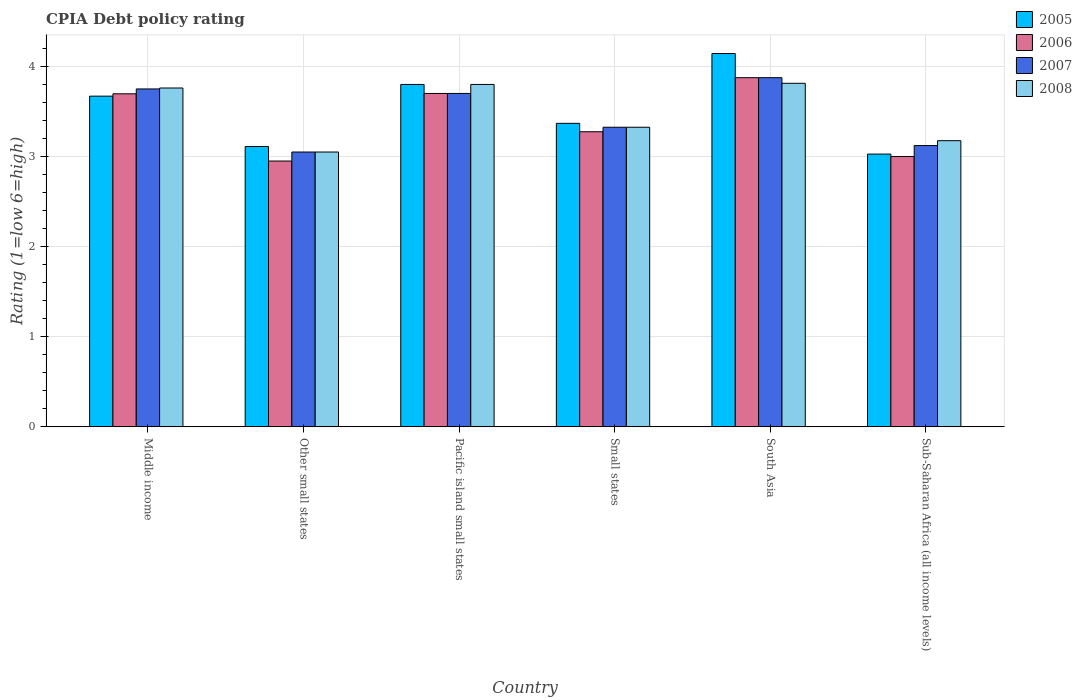How many groups of bars are there?
Your answer should be very brief. 6. How many bars are there on the 4th tick from the left?
Make the answer very short. 4. What is the label of the 4th group of bars from the left?
Your answer should be very brief. Small states. What is the CPIA rating in 2005 in Small states?
Offer a terse response. 3.37. Across all countries, what is the maximum CPIA rating in 2008?
Your answer should be compact. 3.81. Across all countries, what is the minimum CPIA rating in 2005?
Offer a terse response. 3.03. In which country was the CPIA rating in 2007 minimum?
Your answer should be very brief. Other small states. What is the total CPIA rating in 2008 in the graph?
Your answer should be compact. 20.92. What is the difference between the CPIA rating in 2006 in Middle income and that in Sub-Saharan Africa (all income levels)?
Provide a short and direct response. 0.7. What is the difference between the CPIA rating in 2005 in Other small states and the CPIA rating in 2006 in Small states?
Make the answer very short. -0.16. What is the average CPIA rating in 2007 per country?
Keep it short and to the point. 3.47. What is the difference between the CPIA rating of/in 2008 and CPIA rating of/in 2007 in Middle income?
Your answer should be very brief. 0.01. In how many countries, is the CPIA rating in 2006 greater than 2.6?
Ensure brevity in your answer.  6. What is the ratio of the CPIA rating in 2006 in Middle income to that in Sub-Saharan Africa (all income levels)?
Give a very brief answer. 1.23. What is the difference between the highest and the second highest CPIA rating in 2005?
Ensure brevity in your answer.  -0.13. What is the difference between the highest and the lowest CPIA rating in 2005?
Provide a short and direct response. 1.12. In how many countries, is the CPIA rating in 2007 greater than the average CPIA rating in 2007 taken over all countries?
Offer a terse response. 3. Is the sum of the CPIA rating in 2006 in Middle income and Pacific island small states greater than the maximum CPIA rating in 2008 across all countries?
Keep it short and to the point. Yes. What does the 4th bar from the left in Middle income represents?
Provide a short and direct response. 2008. What does the 1st bar from the right in Middle income represents?
Offer a terse response. 2008. Is it the case that in every country, the sum of the CPIA rating in 2007 and CPIA rating in 2006 is greater than the CPIA rating in 2008?
Provide a short and direct response. Yes. How many bars are there?
Keep it short and to the point. 24. Are all the bars in the graph horizontal?
Provide a succinct answer. No. Does the graph contain any zero values?
Offer a terse response. No. Does the graph contain grids?
Keep it short and to the point. Yes. Where does the legend appear in the graph?
Offer a very short reply. Top right. How many legend labels are there?
Ensure brevity in your answer.  4. What is the title of the graph?
Give a very brief answer. CPIA Debt policy rating. What is the label or title of the X-axis?
Your answer should be compact. Country. What is the Rating (1=low 6=high) of 2005 in Middle income?
Provide a short and direct response. 3.67. What is the Rating (1=low 6=high) of 2006 in Middle income?
Your response must be concise. 3.7. What is the Rating (1=low 6=high) of 2007 in Middle income?
Keep it short and to the point. 3.75. What is the Rating (1=low 6=high) in 2008 in Middle income?
Your answer should be compact. 3.76. What is the Rating (1=low 6=high) of 2005 in Other small states?
Provide a succinct answer. 3.11. What is the Rating (1=low 6=high) in 2006 in Other small states?
Your answer should be compact. 2.95. What is the Rating (1=low 6=high) of 2007 in Other small states?
Give a very brief answer. 3.05. What is the Rating (1=low 6=high) of 2008 in Other small states?
Your answer should be compact. 3.05. What is the Rating (1=low 6=high) in 2005 in Pacific island small states?
Your answer should be compact. 3.8. What is the Rating (1=low 6=high) in 2006 in Pacific island small states?
Give a very brief answer. 3.7. What is the Rating (1=low 6=high) of 2007 in Pacific island small states?
Your answer should be compact. 3.7. What is the Rating (1=low 6=high) of 2005 in Small states?
Your response must be concise. 3.37. What is the Rating (1=low 6=high) of 2006 in Small states?
Your answer should be compact. 3.27. What is the Rating (1=low 6=high) of 2007 in Small states?
Ensure brevity in your answer.  3.33. What is the Rating (1=low 6=high) in 2008 in Small states?
Provide a short and direct response. 3.33. What is the Rating (1=low 6=high) in 2005 in South Asia?
Make the answer very short. 4.14. What is the Rating (1=low 6=high) in 2006 in South Asia?
Your response must be concise. 3.88. What is the Rating (1=low 6=high) of 2007 in South Asia?
Ensure brevity in your answer.  3.88. What is the Rating (1=low 6=high) in 2008 in South Asia?
Provide a succinct answer. 3.81. What is the Rating (1=low 6=high) in 2005 in Sub-Saharan Africa (all income levels)?
Ensure brevity in your answer.  3.03. What is the Rating (1=low 6=high) of 2006 in Sub-Saharan Africa (all income levels)?
Your response must be concise. 3. What is the Rating (1=low 6=high) of 2007 in Sub-Saharan Africa (all income levels)?
Your answer should be compact. 3.12. What is the Rating (1=low 6=high) of 2008 in Sub-Saharan Africa (all income levels)?
Provide a succinct answer. 3.18. Across all countries, what is the maximum Rating (1=low 6=high) in 2005?
Ensure brevity in your answer.  4.14. Across all countries, what is the maximum Rating (1=low 6=high) of 2006?
Give a very brief answer. 3.88. Across all countries, what is the maximum Rating (1=low 6=high) in 2007?
Make the answer very short. 3.88. Across all countries, what is the maximum Rating (1=low 6=high) in 2008?
Offer a terse response. 3.81. Across all countries, what is the minimum Rating (1=low 6=high) of 2005?
Keep it short and to the point. 3.03. Across all countries, what is the minimum Rating (1=low 6=high) of 2006?
Offer a very short reply. 2.95. Across all countries, what is the minimum Rating (1=low 6=high) of 2007?
Keep it short and to the point. 3.05. Across all countries, what is the minimum Rating (1=low 6=high) in 2008?
Provide a short and direct response. 3.05. What is the total Rating (1=low 6=high) of 2005 in the graph?
Your response must be concise. 21.12. What is the total Rating (1=low 6=high) in 2006 in the graph?
Give a very brief answer. 20.5. What is the total Rating (1=low 6=high) in 2007 in the graph?
Provide a short and direct response. 20.82. What is the total Rating (1=low 6=high) in 2008 in the graph?
Give a very brief answer. 20.92. What is the difference between the Rating (1=low 6=high) of 2005 in Middle income and that in Other small states?
Your response must be concise. 0.56. What is the difference between the Rating (1=low 6=high) of 2006 in Middle income and that in Other small states?
Keep it short and to the point. 0.75. What is the difference between the Rating (1=low 6=high) in 2007 in Middle income and that in Other small states?
Your answer should be very brief. 0.7. What is the difference between the Rating (1=low 6=high) in 2008 in Middle income and that in Other small states?
Make the answer very short. 0.71. What is the difference between the Rating (1=low 6=high) in 2005 in Middle income and that in Pacific island small states?
Give a very brief answer. -0.13. What is the difference between the Rating (1=low 6=high) in 2006 in Middle income and that in Pacific island small states?
Your response must be concise. -0. What is the difference between the Rating (1=low 6=high) in 2008 in Middle income and that in Pacific island small states?
Give a very brief answer. -0.04. What is the difference between the Rating (1=low 6=high) of 2005 in Middle income and that in Small states?
Offer a very short reply. 0.3. What is the difference between the Rating (1=low 6=high) in 2006 in Middle income and that in Small states?
Give a very brief answer. 0.42. What is the difference between the Rating (1=low 6=high) of 2007 in Middle income and that in Small states?
Provide a succinct answer. 0.42. What is the difference between the Rating (1=low 6=high) of 2008 in Middle income and that in Small states?
Make the answer very short. 0.44. What is the difference between the Rating (1=low 6=high) in 2005 in Middle income and that in South Asia?
Offer a very short reply. -0.47. What is the difference between the Rating (1=low 6=high) of 2006 in Middle income and that in South Asia?
Provide a succinct answer. -0.18. What is the difference between the Rating (1=low 6=high) in 2007 in Middle income and that in South Asia?
Your response must be concise. -0.12. What is the difference between the Rating (1=low 6=high) of 2008 in Middle income and that in South Asia?
Offer a terse response. -0.05. What is the difference between the Rating (1=low 6=high) of 2005 in Middle income and that in Sub-Saharan Africa (all income levels)?
Your answer should be compact. 0.64. What is the difference between the Rating (1=low 6=high) of 2006 in Middle income and that in Sub-Saharan Africa (all income levels)?
Provide a short and direct response. 0.7. What is the difference between the Rating (1=low 6=high) in 2007 in Middle income and that in Sub-Saharan Africa (all income levels)?
Give a very brief answer. 0.63. What is the difference between the Rating (1=low 6=high) in 2008 in Middle income and that in Sub-Saharan Africa (all income levels)?
Provide a succinct answer. 0.58. What is the difference between the Rating (1=low 6=high) in 2005 in Other small states and that in Pacific island small states?
Provide a succinct answer. -0.69. What is the difference between the Rating (1=low 6=high) of 2006 in Other small states and that in Pacific island small states?
Keep it short and to the point. -0.75. What is the difference between the Rating (1=low 6=high) in 2007 in Other small states and that in Pacific island small states?
Offer a very short reply. -0.65. What is the difference between the Rating (1=low 6=high) in 2008 in Other small states and that in Pacific island small states?
Keep it short and to the point. -0.75. What is the difference between the Rating (1=low 6=high) of 2005 in Other small states and that in Small states?
Provide a short and direct response. -0.26. What is the difference between the Rating (1=low 6=high) of 2006 in Other small states and that in Small states?
Keep it short and to the point. -0.33. What is the difference between the Rating (1=low 6=high) in 2007 in Other small states and that in Small states?
Keep it short and to the point. -0.28. What is the difference between the Rating (1=low 6=high) in 2008 in Other small states and that in Small states?
Offer a very short reply. -0.28. What is the difference between the Rating (1=low 6=high) in 2005 in Other small states and that in South Asia?
Offer a very short reply. -1.03. What is the difference between the Rating (1=low 6=high) in 2006 in Other small states and that in South Asia?
Keep it short and to the point. -0.93. What is the difference between the Rating (1=low 6=high) of 2007 in Other small states and that in South Asia?
Provide a short and direct response. -0.82. What is the difference between the Rating (1=low 6=high) in 2008 in Other small states and that in South Asia?
Keep it short and to the point. -0.76. What is the difference between the Rating (1=low 6=high) in 2005 in Other small states and that in Sub-Saharan Africa (all income levels)?
Make the answer very short. 0.08. What is the difference between the Rating (1=low 6=high) in 2006 in Other small states and that in Sub-Saharan Africa (all income levels)?
Offer a terse response. -0.05. What is the difference between the Rating (1=low 6=high) of 2007 in Other small states and that in Sub-Saharan Africa (all income levels)?
Provide a short and direct response. -0.07. What is the difference between the Rating (1=low 6=high) of 2008 in Other small states and that in Sub-Saharan Africa (all income levels)?
Provide a succinct answer. -0.13. What is the difference between the Rating (1=low 6=high) of 2005 in Pacific island small states and that in Small states?
Offer a very short reply. 0.43. What is the difference between the Rating (1=low 6=high) of 2006 in Pacific island small states and that in Small states?
Give a very brief answer. 0.42. What is the difference between the Rating (1=low 6=high) in 2008 in Pacific island small states and that in Small states?
Provide a succinct answer. 0.47. What is the difference between the Rating (1=low 6=high) in 2005 in Pacific island small states and that in South Asia?
Your response must be concise. -0.34. What is the difference between the Rating (1=low 6=high) of 2006 in Pacific island small states and that in South Asia?
Your answer should be very brief. -0.17. What is the difference between the Rating (1=low 6=high) in 2007 in Pacific island small states and that in South Asia?
Give a very brief answer. -0.17. What is the difference between the Rating (1=low 6=high) in 2008 in Pacific island small states and that in South Asia?
Your answer should be very brief. -0.01. What is the difference between the Rating (1=low 6=high) of 2005 in Pacific island small states and that in Sub-Saharan Africa (all income levels)?
Your answer should be very brief. 0.77. What is the difference between the Rating (1=low 6=high) of 2007 in Pacific island small states and that in Sub-Saharan Africa (all income levels)?
Your response must be concise. 0.58. What is the difference between the Rating (1=low 6=high) of 2008 in Pacific island small states and that in Sub-Saharan Africa (all income levels)?
Give a very brief answer. 0.62. What is the difference between the Rating (1=low 6=high) of 2005 in Small states and that in South Asia?
Give a very brief answer. -0.77. What is the difference between the Rating (1=low 6=high) of 2006 in Small states and that in South Asia?
Provide a succinct answer. -0.6. What is the difference between the Rating (1=low 6=high) in 2007 in Small states and that in South Asia?
Offer a terse response. -0.55. What is the difference between the Rating (1=low 6=high) in 2008 in Small states and that in South Asia?
Make the answer very short. -0.49. What is the difference between the Rating (1=low 6=high) of 2005 in Small states and that in Sub-Saharan Africa (all income levels)?
Provide a short and direct response. 0.34. What is the difference between the Rating (1=low 6=high) of 2006 in Small states and that in Sub-Saharan Africa (all income levels)?
Offer a very short reply. 0.28. What is the difference between the Rating (1=low 6=high) in 2007 in Small states and that in Sub-Saharan Africa (all income levels)?
Your answer should be compact. 0.2. What is the difference between the Rating (1=low 6=high) of 2008 in Small states and that in Sub-Saharan Africa (all income levels)?
Offer a terse response. 0.15. What is the difference between the Rating (1=low 6=high) in 2005 in South Asia and that in Sub-Saharan Africa (all income levels)?
Make the answer very short. 1.12. What is the difference between the Rating (1=low 6=high) of 2007 in South Asia and that in Sub-Saharan Africa (all income levels)?
Ensure brevity in your answer.  0.75. What is the difference between the Rating (1=low 6=high) in 2008 in South Asia and that in Sub-Saharan Africa (all income levels)?
Your answer should be compact. 0.64. What is the difference between the Rating (1=low 6=high) of 2005 in Middle income and the Rating (1=low 6=high) of 2006 in Other small states?
Your answer should be very brief. 0.72. What is the difference between the Rating (1=low 6=high) in 2005 in Middle income and the Rating (1=low 6=high) in 2007 in Other small states?
Your answer should be very brief. 0.62. What is the difference between the Rating (1=low 6=high) in 2005 in Middle income and the Rating (1=low 6=high) in 2008 in Other small states?
Your answer should be compact. 0.62. What is the difference between the Rating (1=low 6=high) of 2006 in Middle income and the Rating (1=low 6=high) of 2007 in Other small states?
Your answer should be compact. 0.65. What is the difference between the Rating (1=low 6=high) of 2006 in Middle income and the Rating (1=low 6=high) of 2008 in Other small states?
Ensure brevity in your answer.  0.65. What is the difference between the Rating (1=low 6=high) of 2005 in Middle income and the Rating (1=low 6=high) of 2006 in Pacific island small states?
Provide a succinct answer. -0.03. What is the difference between the Rating (1=low 6=high) of 2005 in Middle income and the Rating (1=low 6=high) of 2007 in Pacific island small states?
Keep it short and to the point. -0.03. What is the difference between the Rating (1=low 6=high) of 2005 in Middle income and the Rating (1=low 6=high) of 2008 in Pacific island small states?
Offer a very short reply. -0.13. What is the difference between the Rating (1=low 6=high) of 2006 in Middle income and the Rating (1=low 6=high) of 2007 in Pacific island small states?
Provide a succinct answer. -0. What is the difference between the Rating (1=low 6=high) in 2006 in Middle income and the Rating (1=low 6=high) in 2008 in Pacific island small states?
Your response must be concise. -0.1. What is the difference between the Rating (1=low 6=high) in 2005 in Middle income and the Rating (1=low 6=high) in 2006 in Small states?
Make the answer very short. 0.4. What is the difference between the Rating (1=low 6=high) of 2005 in Middle income and the Rating (1=low 6=high) of 2007 in Small states?
Ensure brevity in your answer.  0.34. What is the difference between the Rating (1=low 6=high) of 2005 in Middle income and the Rating (1=low 6=high) of 2008 in Small states?
Your answer should be compact. 0.34. What is the difference between the Rating (1=low 6=high) in 2006 in Middle income and the Rating (1=low 6=high) in 2007 in Small states?
Offer a terse response. 0.37. What is the difference between the Rating (1=low 6=high) of 2006 in Middle income and the Rating (1=low 6=high) of 2008 in Small states?
Provide a succinct answer. 0.37. What is the difference between the Rating (1=low 6=high) in 2007 in Middle income and the Rating (1=low 6=high) in 2008 in Small states?
Offer a very short reply. 0.42. What is the difference between the Rating (1=low 6=high) of 2005 in Middle income and the Rating (1=low 6=high) of 2006 in South Asia?
Your answer should be very brief. -0.2. What is the difference between the Rating (1=low 6=high) of 2005 in Middle income and the Rating (1=low 6=high) of 2007 in South Asia?
Your answer should be compact. -0.2. What is the difference between the Rating (1=low 6=high) of 2005 in Middle income and the Rating (1=low 6=high) of 2008 in South Asia?
Your response must be concise. -0.14. What is the difference between the Rating (1=low 6=high) of 2006 in Middle income and the Rating (1=low 6=high) of 2007 in South Asia?
Provide a succinct answer. -0.18. What is the difference between the Rating (1=low 6=high) in 2006 in Middle income and the Rating (1=low 6=high) in 2008 in South Asia?
Keep it short and to the point. -0.12. What is the difference between the Rating (1=low 6=high) of 2007 in Middle income and the Rating (1=low 6=high) of 2008 in South Asia?
Make the answer very short. -0.06. What is the difference between the Rating (1=low 6=high) of 2005 in Middle income and the Rating (1=low 6=high) of 2006 in Sub-Saharan Africa (all income levels)?
Offer a very short reply. 0.67. What is the difference between the Rating (1=low 6=high) in 2005 in Middle income and the Rating (1=low 6=high) in 2007 in Sub-Saharan Africa (all income levels)?
Offer a very short reply. 0.55. What is the difference between the Rating (1=low 6=high) of 2005 in Middle income and the Rating (1=low 6=high) of 2008 in Sub-Saharan Africa (all income levels)?
Your answer should be very brief. 0.49. What is the difference between the Rating (1=low 6=high) of 2006 in Middle income and the Rating (1=low 6=high) of 2007 in Sub-Saharan Africa (all income levels)?
Your response must be concise. 0.57. What is the difference between the Rating (1=low 6=high) in 2006 in Middle income and the Rating (1=low 6=high) in 2008 in Sub-Saharan Africa (all income levels)?
Your answer should be compact. 0.52. What is the difference between the Rating (1=low 6=high) of 2007 in Middle income and the Rating (1=low 6=high) of 2008 in Sub-Saharan Africa (all income levels)?
Your answer should be very brief. 0.57. What is the difference between the Rating (1=low 6=high) of 2005 in Other small states and the Rating (1=low 6=high) of 2006 in Pacific island small states?
Make the answer very short. -0.59. What is the difference between the Rating (1=low 6=high) in 2005 in Other small states and the Rating (1=low 6=high) in 2007 in Pacific island small states?
Offer a very short reply. -0.59. What is the difference between the Rating (1=low 6=high) in 2005 in Other small states and the Rating (1=low 6=high) in 2008 in Pacific island small states?
Your response must be concise. -0.69. What is the difference between the Rating (1=low 6=high) of 2006 in Other small states and the Rating (1=low 6=high) of 2007 in Pacific island small states?
Ensure brevity in your answer.  -0.75. What is the difference between the Rating (1=low 6=high) in 2006 in Other small states and the Rating (1=low 6=high) in 2008 in Pacific island small states?
Make the answer very short. -0.85. What is the difference between the Rating (1=low 6=high) in 2007 in Other small states and the Rating (1=low 6=high) in 2008 in Pacific island small states?
Offer a terse response. -0.75. What is the difference between the Rating (1=low 6=high) of 2005 in Other small states and the Rating (1=low 6=high) of 2006 in Small states?
Keep it short and to the point. -0.16. What is the difference between the Rating (1=low 6=high) of 2005 in Other small states and the Rating (1=low 6=high) of 2007 in Small states?
Give a very brief answer. -0.21. What is the difference between the Rating (1=low 6=high) of 2005 in Other small states and the Rating (1=low 6=high) of 2008 in Small states?
Provide a succinct answer. -0.21. What is the difference between the Rating (1=low 6=high) of 2006 in Other small states and the Rating (1=low 6=high) of 2007 in Small states?
Your answer should be very brief. -0.38. What is the difference between the Rating (1=low 6=high) in 2006 in Other small states and the Rating (1=low 6=high) in 2008 in Small states?
Your answer should be very brief. -0.38. What is the difference between the Rating (1=low 6=high) of 2007 in Other small states and the Rating (1=low 6=high) of 2008 in Small states?
Provide a short and direct response. -0.28. What is the difference between the Rating (1=low 6=high) in 2005 in Other small states and the Rating (1=low 6=high) in 2006 in South Asia?
Give a very brief answer. -0.76. What is the difference between the Rating (1=low 6=high) of 2005 in Other small states and the Rating (1=low 6=high) of 2007 in South Asia?
Provide a short and direct response. -0.76. What is the difference between the Rating (1=low 6=high) of 2005 in Other small states and the Rating (1=low 6=high) of 2008 in South Asia?
Provide a short and direct response. -0.7. What is the difference between the Rating (1=low 6=high) of 2006 in Other small states and the Rating (1=low 6=high) of 2007 in South Asia?
Ensure brevity in your answer.  -0.93. What is the difference between the Rating (1=low 6=high) in 2006 in Other small states and the Rating (1=low 6=high) in 2008 in South Asia?
Make the answer very short. -0.86. What is the difference between the Rating (1=low 6=high) in 2007 in Other small states and the Rating (1=low 6=high) in 2008 in South Asia?
Give a very brief answer. -0.76. What is the difference between the Rating (1=low 6=high) of 2005 in Other small states and the Rating (1=low 6=high) of 2007 in Sub-Saharan Africa (all income levels)?
Your response must be concise. -0.01. What is the difference between the Rating (1=low 6=high) of 2005 in Other small states and the Rating (1=low 6=high) of 2008 in Sub-Saharan Africa (all income levels)?
Provide a succinct answer. -0.06. What is the difference between the Rating (1=low 6=high) of 2006 in Other small states and the Rating (1=low 6=high) of 2007 in Sub-Saharan Africa (all income levels)?
Your response must be concise. -0.17. What is the difference between the Rating (1=low 6=high) in 2006 in Other small states and the Rating (1=low 6=high) in 2008 in Sub-Saharan Africa (all income levels)?
Ensure brevity in your answer.  -0.23. What is the difference between the Rating (1=low 6=high) in 2007 in Other small states and the Rating (1=low 6=high) in 2008 in Sub-Saharan Africa (all income levels)?
Offer a terse response. -0.13. What is the difference between the Rating (1=low 6=high) of 2005 in Pacific island small states and the Rating (1=low 6=high) of 2006 in Small states?
Your answer should be compact. 0.53. What is the difference between the Rating (1=low 6=high) of 2005 in Pacific island small states and the Rating (1=low 6=high) of 2007 in Small states?
Provide a short and direct response. 0.47. What is the difference between the Rating (1=low 6=high) of 2005 in Pacific island small states and the Rating (1=low 6=high) of 2008 in Small states?
Offer a very short reply. 0.47. What is the difference between the Rating (1=low 6=high) in 2007 in Pacific island small states and the Rating (1=low 6=high) in 2008 in Small states?
Give a very brief answer. 0.38. What is the difference between the Rating (1=low 6=high) in 2005 in Pacific island small states and the Rating (1=low 6=high) in 2006 in South Asia?
Give a very brief answer. -0.07. What is the difference between the Rating (1=low 6=high) in 2005 in Pacific island small states and the Rating (1=low 6=high) in 2007 in South Asia?
Make the answer very short. -0.07. What is the difference between the Rating (1=low 6=high) of 2005 in Pacific island small states and the Rating (1=low 6=high) of 2008 in South Asia?
Keep it short and to the point. -0.01. What is the difference between the Rating (1=low 6=high) of 2006 in Pacific island small states and the Rating (1=low 6=high) of 2007 in South Asia?
Keep it short and to the point. -0.17. What is the difference between the Rating (1=low 6=high) of 2006 in Pacific island small states and the Rating (1=low 6=high) of 2008 in South Asia?
Make the answer very short. -0.11. What is the difference between the Rating (1=low 6=high) in 2007 in Pacific island small states and the Rating (1=low 6=high) in 2008 in South Asia?
Provide a succinct answer. -0.11. What is the difference between the Rating (1=low 6=high) of 2005 in Pacific island small states and the Rating (1=low 6=high) of 2006 in Sub-Saharan Africa (all income levels)?
Make the answer very short. 0.8. What is the difference between the Rating (1=low 6=high) in 2005 in Pacific island small states and the Rating (1=low 6=high) in 2007 in Sub-Saharan Africa (all income levels)?
Give a very brief answer. 0.68. What is the difference between the Rating (1=low 6=high) of 2005 in Pacific island small states and the Rating (1=low 6=high) of 2008 in Sub-Saharan Africa (all income levels)?
Offer a terse response. 0.62. What is the difference between the Rating (1=low 6=high) in 2006 in Pacific island small states and the Rating (1=low 6=high) in 2007 in Sub-Saharan Africa (all income levels)?
Make the answer very short. 0.58. What is the difference between the Rating (1=low 6=high) of 2006 in Pacific island small states and the Rating (1=low 6=high) of 2008 in Sub-Saharan Africa (all income levels)?
Make the answer very short. 0.52. What is the difference between the Rating (1=low 6=high) in 2007 in Pacific island small states and the Rating (1=low 6=high) in 2008 in Sub-Saharan Africa (all income levels)?
Provide a short and direct response. 0.52. What is the difference between the Rating (1=low 6=high) of 2005 in Small states and the Rating (1=low 6=high) of 2006 in South Asia?
Give a very brief answer. -0.51. What is the difference between the Rating (1=low 6=high) in 2005 in Small states and the Rating (1=low 6=high) in 2007 in South Asia?
Give a very brief answer. -0.51. What is the difference between the Rating (1=low 6=high) of 2005 in Small states and the Rating (1=low 6=high) of 2008 in South Asia?
Make the answer very short. -0.44. What is the difference between the Rating (1=low 6=high) of 2006 in Small states and the Rating (1=low 6=high) of 2008 in South Asia?
Give a very brief answer. -0.54. What is the difference between the Rating (1=low 6=high) in 2007 in Small states and the Rating (1=low 6=high) in 2008 in South Asia?
Offer a terse response. -0.49. What is the difference between the Rating (1=low 6=high) of 2005 in Small states and the Rating (1=low 6=high) of 2006 in Sub-Saharan Africa (all income levels)?
Offer a terse response. 0.37. What is the difference between the Rating (1=low 6=high) in 2005 in Small states and the Rating (1=low 6=high) in 2007 in Sub-Saharan Africa (all income levels)?
Provide a short and direct response. 0.25. What is the difference between the Rating (1=low 6=high) of 2005 in Small states and the Rating (1=low 6=high) of 2008 in Sub-Saharan Africa (all income levels)?
Offer a very short reply. 0.19. What is the difference between the Rating (1=low 6=high) of 2006 in Small states and the Rating (1=low 6=high) of 2007 in Sub-Saharan Africa (all income levels)?
Give a very brief answer. 0.15. What is the difference between the Rating (1=low 6=high) of 2006 in Small states and the Rating (1=low 6=high) of 2008 in Sub-Saharan Africa (all income levels)?
Offer a very short reply. 0.1. What is the difference between the Rating (1=low 6=high) of 2007 in Small states and the Rating (1=low 6=high) of 2008 in Sub-Saharan Africa (all income levels)?
Provide a succinct answer. 0.15. What is the difference between the Rating (1=low 6=high) of 2005 in South Asia and the Rating (1=low 6=high) of 2007 in Sub-Saharan Africa (all income levels)?
Your answer should be very brief. 1.02. What is the difference between the Rating (1=low 6=high) of 2005 in South Asia and the Rating (1=low 6=high) of 2008 in Sub-Saharan Africa (all income levels)?
Your answer should be compact. 0.97. What is the difference between the Rating (1=low 6=high) in 2006 in South Asia and the Rating (1=low 6=high) in 2007 in Sub-Saharan Africa (all income levels)?
Your answer should be very brief. 0.75. What is the difference between the Rating (1=low 6=high) of 2006 in South Asia and the Rating (1=low 6=high) of 2008 in Sub-Saharan Africa (all income levels)?
Provide a short and direct response. 0.7. What is the difference between the Rating (1=low 6=high) in 2007 in South Asia and the Rating (1=low 6=high) in 2008 in Sub-Saharan Africa (all income levels)?
Your answer should be very brief. 0.7. What is the average Rating (1=low 6=high) in 2005 per country?
Offer a very short reply. 3.52. What is the average Rating (1=low 6=high) of 2006 per country?
Make the answer very short. 3.42. What is the average Rating (1=low 6=high) of 2007 per country?
Offer a very short reply. 3.47. What is the average Rating (1=low 6=high) of 2008 per country?
Keep it short and to the point. 3.49. What is the difference between the Rating (1=low 6=high) in 2005 and Rating (1=low 6=high) in 2006 in Middle income?
Offer a terse response. -0.03. What is the difference between the Rating (1=low 6=high) in 2005 and Rating (1=low 6=high) in 2007 in Middle income?
Offer a terse response. -0.08. What is the difference between the Rating (1=low 6=high) of 2005 and Rating (1=low 6=high) of 2008 in Middle income?
Ensure brevity in your answer.  -0.09. What is the difference between the Rating (1=low 6=high) of 2006 and Rating (1=low 6=high) of 2007 in Middle income?
Make the answer very short. -0.05. What is the difference between the Rating (1=low 6=high) in 2006 and Rating (1=low 6=high) in 2008 in Middle income?
Your answer should be very brief. -0.06. What is the difference between the Rating (1=low 6=high) of 2007 and Rating (1=low 6=high) of 2008 in Middle income?
Provide a succinct answer. -0.01. What is the difference between the Rating (1=low 6=high) in 2005 and Rating (1=low 6=high) in 2006 in Other small states?
Provide a short and direct response. 0.16. What is the difference between the Rating (1=low 6=high) in 2005 and Rating (1=low 6=high) in 2007 in Other small states?
Make the answer very short. 0.06. What is the difference between the Rating (1=low 6=high) in 2005 and Rating (1=low 6=high) in 2008 in Other small states?
Provide a succinct answer. 0.06. What is the difference between the Rating (1=low 6=high) in 2007 and Rating (1=low 6=high) in 2008 in Other small states?
Give a very brief answer. 0. What is the difference between the Rating (1=low 6=high) of 2005 and Rating (1=low 6=high) of 2006 in Pacific island small states?
Provide a succinct answer. 0.1. What is the difference between the Rating (1=low 6=high) in 2005 and Rating (1=low 6=high) in 2008 in Pacific island small states?
Make the answer very short. 0. What is the difference between the Rating (1=low 6=high) of 2006 and Rating (1=low 6=high) of 2008 in Pacific island small states?
Offer a very short reply. -0.1. What is the difference between the Rating (1=low 6=high) in 2007 and Rating (1=low 6=high) in 2008 in Pacific island small states?
Provide a succinct answer. -0.1. What is the difference between the Rating (1=low 6=high) of 2005 and Rating (1=low 6=high) of 2006 in Small states?
Your answer should be compact. 0.09. What is the difference between the Rating (1=low 6=high) of 2005 and Rating (1=low 6=high) of 2007 in Small states?
Provide a short and direct response. 0.04. What is the difference between the Rating (1=low 6=high) of 2005 and Rating (1=low 6=high) of 2008 in Small states?
Provide a succinct answer. 0.04. What is the difference between the Rating (1=low 6=high) in 2006 and Rating (1=low 6=high) in 2007 in Small states?
Your response must be concise. -0.05. What is the difference between the Rating (1=low 6=high) in 2006 and Rating (1=low 6=high) in 2008 in Small states?
Make the answer very short. -0.05. What is the difference between the Rating (1=low 6=high) in 2005 and Rating (1=low 6=high) in 2006 in South Asia?
Your answer should be very brief. 0.27. What is the difference between the Rating (1=low 6=high) of 2005 and Rating (1=low 6=high) of 2007 in South Asia?
Provide a short and direct response. 0.27. What is the difference between the Rating (1=low 6=high) of 2005 and Rating (1=low 6=high) of 2008 in South Asia?
Ensure brevity in your answer.  0.33. What is the difference between the Rating (1=low 6=high) in 2006 and Rating (1=low 6=high) in 2007 in South Asia?
Ensure brevity in your answer.  0. What is the difference between the Rating (1=low 6=high) of 2006 and Rating (1=low 6=high) of 2008 in South Asia?
Your answer should be very brief. 0.06. What is the difference between the Rating (1=low 6=high) of 2007 and Rating (1=low 6=high) of 2008 in South Asia?
Offer a terse response. 0.06. What is the difference between the Rating (1=low 6=high) of 2005 and Rating (1=low 6=high) of 2006 in Sub-Saharan Africa (all income levels)?
Provide a short and direct response. 0.03. What is the difference between the Rating (1=low 6=high) of 2005 and Rating (1=low 6=high) of 2007 in Sub-Saharan Africa (all income levels)?
Give a very brief answer. -0.09. What is the difference between the Rating (1=low 6=high) in 2005 and Rating (1=low 6=high) in 2008 in Sub-Saharan Africa (all income levels)?
Make the answer very short. -0.15. What is the difference between the Rating (1=low 6=high) of 2006 and Rating (1=low 6=high) of 2007 in Sub-Saharan Africa (all income levels)?
Offer a terse response. -0.12. What is the difference between the Rating (1=low 6=high) of 2006 and Rating (1=low 6=high) of 2008 in Sub-Saharan Africa (all income levels)?
Offer a very short reply. -0.18. What is the difference between the Rating (1=low 6=high) in 2007 and Rating (1=low 6=high) in 2008 in Sub-Saharan Africa (all income levels)?
Keep it short and to the point. -0.05. What is the ratio of the Rating (1=low 6=high) of 2005 in Middle income to that in Other small states?
Give a very brief answer. 1.18. What is the ratio of the Rating (1=low 6=high) of 2006 in Middle income to that in Other small states?
Ensure brevity in your answer.  1.25. What is the ratio of the Rating (1=low 6=high) in 2007 in Middle income to that in Other small states?
Offer a very short reply. 1.23. What is the ratio of the Rating (1=low 6=high) of 2008 in Middle income to that in Other small states?
Your answer should be compact. 1.23. What is the ratio of the Rating (1=low 6=high) in 2005 in Middle income to that in Pacific island small states?
Your response must be concise. 0.97. What is the ratio of the Rating (1=low 6=high) of 2007 in Middle income to that in Pacific island small states?
Ensure brevity in your answer.  1.01. What is the ratio of the Rating (1=low 6=high) in 2005 in Middle income to that in Small states?
Give a very brief answer. 1.09. What is the ratio of the Rating (1=low 6=high) in 2006 in Middle income to that in Small states?
Ensure brevity in your answer.  1.13. What is the ratio of the Rating (1=low 6=high) in 2007 in Middle income to that in Small states?
Ensure brevity in your answer.  1.13. What is the ratio of the Rating (1=low 6=high) of 2008 in Middle income to that in Small states?
Your response must be concise. 1.13. What is the ratio of the Rating (1=low 6=high) of 2005 in Middle income to that in South Asia?
Make the answer very short. 0.89. What is the ratio of the Rating (1=low 6=high) in 2006 in Middle income to that in South Asia?
Ensure brevity in your answer.  0.95. What is the ratio of the Rating (1=low 6=high) in 2007 in Middle income to that in South Asia?
Provide a succinct answer. 0.97. What is the ratio of the Rating (1=low 6=high) in 2008 in Middle income to that in South Asia?
Provide a succinct answer. 0.99. What is the ratio of the Rating (1=low 6=high) of 2005 in Middle income to that in Sub-Saharan Africa (all income levels)?
Give a very brief answer. 1.21. What is the ratio of the Rating (1=low 6=high) in 2006 in Middle income to that in Sub-Saharan Africa (all income levels)?
Offer a terse response. 1.23. What is the ratio of the Rating (1=low 6=high) in 2007 in Middle income to that in Sub-Saharan Africa (all income levels)?
Make the answer very short. 1.2. What is the ratio of the Rating (1=low 6=high) of 2008 in Middle income to that in Sub-Saharan Africa (all income levels)?
Your answer should be compact. 1.18. What is the ratio of the Rating (1=low 6=high) in 2005 in Other small states to that in Pacific island small states?
Your response must be concise. 0.82. What is the ratio of the Rating (1=low 6=high) in 2006 in Other small states to that in Pacific island small states?
Your answer should be compact. 0.8. What is the ratio of the Rating (1=low 6=high) in 2007 in Other small states to that in Pacific island small states?
Your response must be concise. 0.82. What is the ratio of the Rating (1=low 6=high) in 2008 in Other small states to that in Pacific island small states?
Your response must be concise. 0.8. What is the ratio of the Rating (1=low 6=high) in 2005 in Other small states to that in Small states?
Offer a terse response. 0.92. What is the ratio of the Rating (1=low 6=high) of 2006 in Other small states to that in Small states?
Offer a very short reply. 0.9. What is the ratio of the Rating (1=low 6=high) of 2007 in Other small states to that in Small states?
Provide a short and direct response. 0.92. What is the ratio of the Rating (1=low 6=high) in 2008 in Other small states to that in Small states?
Offer a very short reply. 0.92. What is the ratio of the Rating (1=low 6=high) of 2005 in Other small states to that in South Asia?
Your answer should be compact. 0.75. What is the ratio of the Rating (1=low 6=high) in 2006 in Other small states to that in South Asia?
Ensure brevity in your answer.  0.76. What is the ratio of the Rating (1=low 6=high) in 2007 in Other small states to that in South Asia?
Provide a short and direct response. 0.79. What is the ratio of the Rating (1=low 6=high) of 2005 in Other small states to that in Sub-Saharan Africa (all income levels)?
Your response must be concise. 1.03. What is the ratio of the Rating (1=low 6=high) of 2006 in Other small states to that in Sub-Saharan Africa (all income levels)?
Offer a very short reply. 0.98. What is the ratio of the Rating (1=low 6=high) in 2007 in Other small states to that in Sub-Saharan Africa (all income levels)?
Provide a succinct answer. 0.98. What is the ratio of the Rating (1=low 6=high) of 2008 in Other small states to that in Sub-Saharan Africa (all income levels)?
Give a very brief answer. 0.96. What is the ratio of the Rating (1=low 6=high) in 2005 in Pacific island small states to that in Small states?
Ensure brevity in your answer.  1.13. What is the ratio of the Rating (1=low 6=high) in 2006 in Pacific island small states to that in Small states?
Make the answer very short. 1.13. What is the ratio of the Rating (1=low 6=high) in 2007 in Pacific island small states to that in Small states?
Make the answer very short. 1.11. What is the ratio of the Rating (1=low 6=high) in 2008 in Pacific island small states to that in Small states?
Provide a succinct answer. 1.14. What is the ratio of the Rating (1=low 6=high) in 2005 in Pacific island small states to that in South Asia?
Provide a short and direct response. 0.92. What is the ratio of the Rating (1=low 6=high) of 2006 in Pacific island small states to that in South Asia?
Make the answer very short. 0.95. What is the ratio of the Rating (1=low 6=high) of 2007 in Pacific island small states to that in South Asia?
Your answer should be very brief. 0.95. What is the ratio of the Rating (1=low 6=high) of 2005 in Pacific island small states to that in Sub-Saharan Africa (all income levels)?
Your response must be concise. 1.26. What is the ratio of the Rating (1=low 6=high) in 2006 in Pacific island small states to that in Sub-Saharan Africa (all income levels)?
Your answer should be very brief. 1.23. What is the ratio of the Rating (1=low 6=high) in 2007 in Pacific island small states to that in Sub-Saharan Africa (all income levels)?
Your response must be concise. 1.19. What is the ratio of the Rating (1=low 6=high) of 2008 in Pacific island small states to that in Sub-Saharan Africa (all income levels)?
Ensure brevity in your answer.  1.2. What is the ratio of the Rating (1=low 6=high) in 2005 in Small states to that in South Asia?
Make the answer very short. 0.81. What is the ratio of the Rating (1=low 6=high) in 2006 in Small states to that in South Asia?
Your response must be concise. 0.85. What is the ratio of the Rating (1=low 6=high) in 2007 in Small states to that in South Asia?
Your answer should be compact. 0.86. What is the ratio of the Rating (1=low 6=high) of 2008 in Small states to that in South Asia?
Make the answer very short. 0.87. What is the ratio of the Rating (1=low 6=high) of 2005 in Small states to that in Sub-Saharan Africa (all income levels)?
Offer a terse response. 1.11. What is the ratio of the Rating (1=low 6=high) in 2006 in Small states to that in Sub-Saharan Africa (all income levels)?
Offer a very short reply. 1.09. What is the ratio of the Rating (1=low 6=high) of 2007 in Small states to that in Sub-Saharan Africa (all income levels)?
Provide a short and direct response. 1.07. What is the ratio of the Rating (1=low 6=high) of 2008 in Small states to that in Sub-Saharan Africa (all income levels)?
Your answer should be very brief. 1.05. What is the ratio of the Rating (1=low 6=high) in 2005 in South Asia to that in Sub-Saharan Africa (all income levels)?
Offer a very short reply. 1.37. What is the ratio of the Rating (1=low 6=high) in 2006 in South Asia to that in Sub-Saharan Africa (all income levels)?
Your answer should be very brief. 1.29. What is the ratio of the Rating (1=low 6=high) in 2007 in South Asia to that in Sub-Saharan Africa (all income levels)?
Keep it short and to the point. 1.24. What is the ratio of the Rating (1=low 6=high) of 2008 in South Asia to that in Sub-Saharan Africa (all income levels)?
Provide a short and direct response. 1.2. What is the difference between the highest and the second highest Rating (1=low 6=high) in 2005?
Provide a succinct answer. 0.34. What is the difference between the highest and the second highest Rating (1=low 6=high) of 2006?
Offer a terse response. 0.17. What is the difference between the highest and the second highest Rating (1=low 6=high) in 2007?
Make the answer very short. 0.12. What is the difference between the highest and the second highest Rating (1=low 6=high) in 2008?
Your response must be concise. 0.01. What is the difference between the highest and the lowest Rating (1=low 6=high) of 2005?
Your answer should be compact. 1.12. What is the difference between the highest and the lowest Rating (1=low 6=high) in 2006?
Your answer should be very brief. 0.93. What is the difference between the highest and the lowest Rating (1=low 6=high) in 2007?
Ensure brevity in your answer.  0.82. What is the difference between the highest and the lowest Rating (1=low 6=high) in 2008?
Offer a terse response. 0.76. 